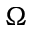<formula> <loc_0><loc_0><loc_500><loc_500>\Omega</formula> 